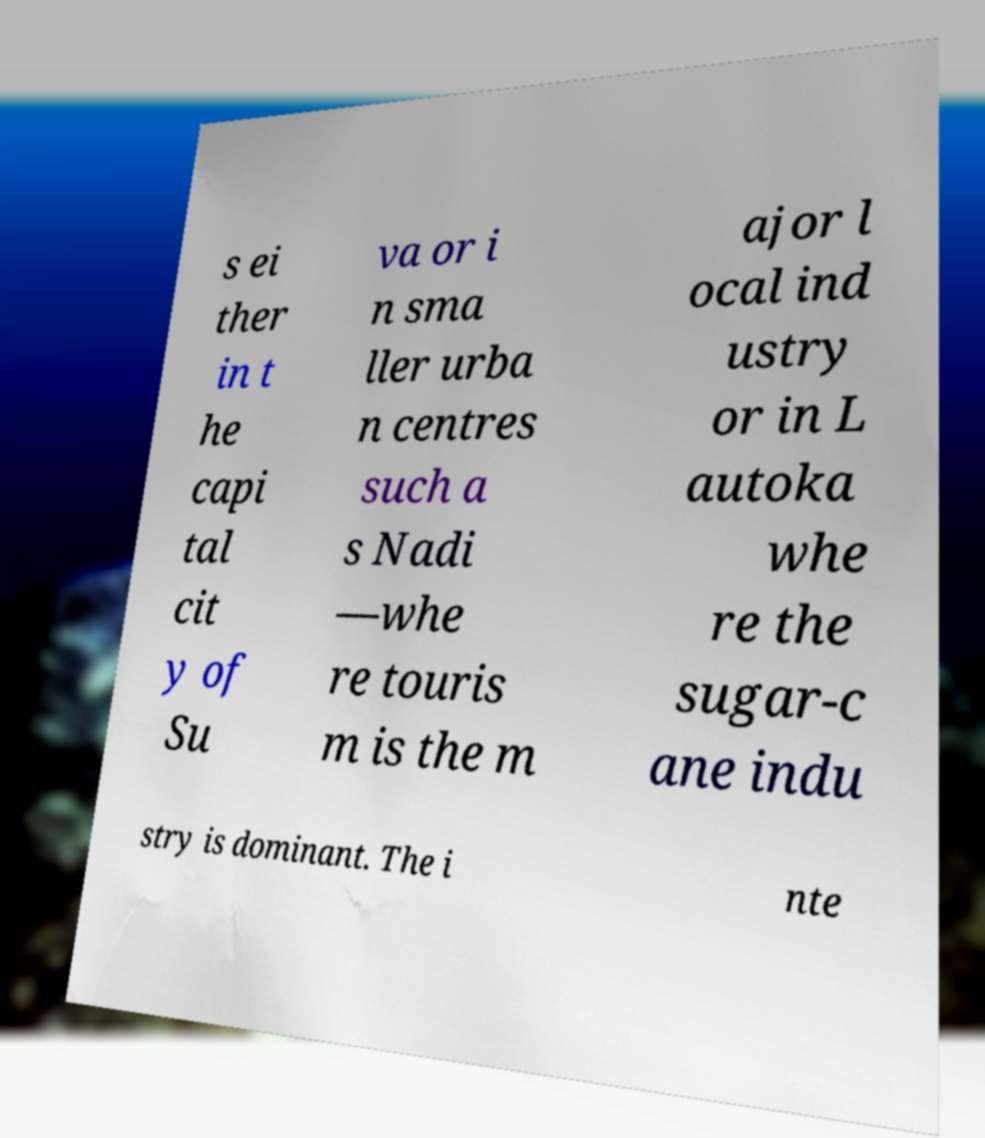For documentation purposes, I need the text within this image transcribed. Could you provide that? s ei ther in t he capi tal cit y of Su va or i n sma ller urba n centres such a s Nadi —whe re touris m is the m ajor l ocal ind ustry or in L autoka whe re the sugar-c ane indu stry is dominant. The i nte 